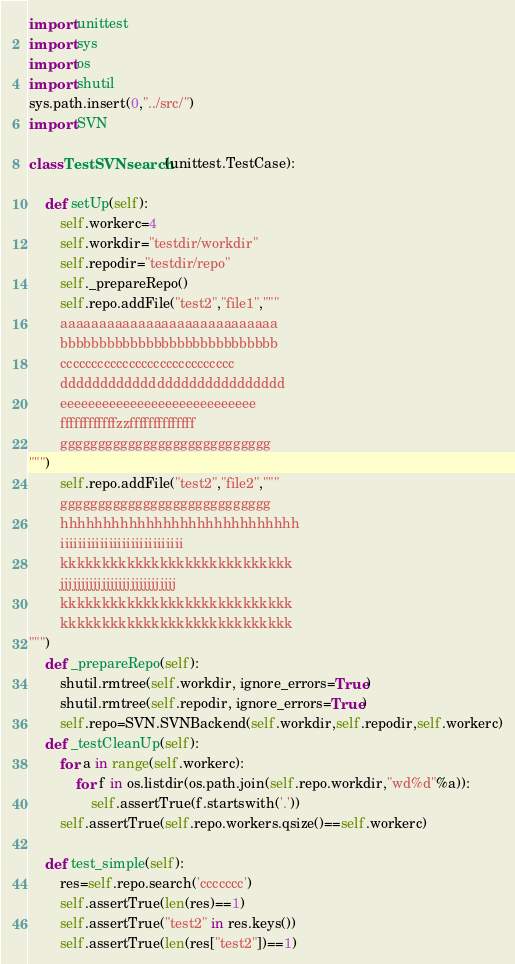Convert code to text. <code><loc_0><loc_0><loc_500><loc_500><_Python_>import unittest
import sys
import os
import shutil
sys.path.insert(0,"../src/")
import SVN

class TestSVNsearch(unittest.TestCase):

	def setUp(self):
		self.workerc=4
		self.workdir="testdir/workdir"
		self.repodir="testdir/repo"
		self._prepareRepo()
		self.repo.addFile("test2","file1","""
		aaaaaaaaaaaaaaaaaaaaaaaaaaaa
		bbbbbbbbbbbbbbbbbbbbbbbbbbbb
		cccccccccccccccccccccccccccc
		dddddddddddddddddddddddddddd
		eeeeeeeeeeeeeeeeeeeeeeeeeeee
		ffffffffffffzzffffffffffffff
		gggggggggggggggggggggggggggg
""")
		self.repo.addFile("test2","file2","""
		gggggggggggggggggggggggggggg
		hhhhhhhhhhhhhhhhhhhhhhhhhhhh
		iiiiiiiiiiiiiiiiiiiiiiiiiiii
		kkkkkkkkkkkkkkkkkkkkkkkkkkkk
		jjjjjjjjjjjjjjjjjjjjjjjjjjjj
		kkkkkkkkkkkkkkkkkkkkkkkkkkkk
		kkkkkkkkkkkkkkkkkkkkkkkkkkkk
""")
	def _prepareRepo(self):
		shutil.rmtree(self.workdir, ignore_errors=True)
		shutil.rmtree(self.repodir, ignore_errors=True)
		self.repo=SVN.SVNBackend(self.workdir,self.repodir,self.workerc)
	def _testCleanUp(self):
		for a in range(self.workerc):
			for f in os.listdir(os.path.join(self.repo.workdir,"wd%d"%a)):
				self.assertTrue(f.startswith('.'))
		self.assertTrue(self.repo.workers.qsize()==self.workerc)

	def test_simple(self):
		res=self.repo.search('ccccccc')
		self.assertTrue(len(res)==1)
		self.assertTrue("test2" in res.keys())
		self.assertTrue(len(res["test2"])==1)</code> 